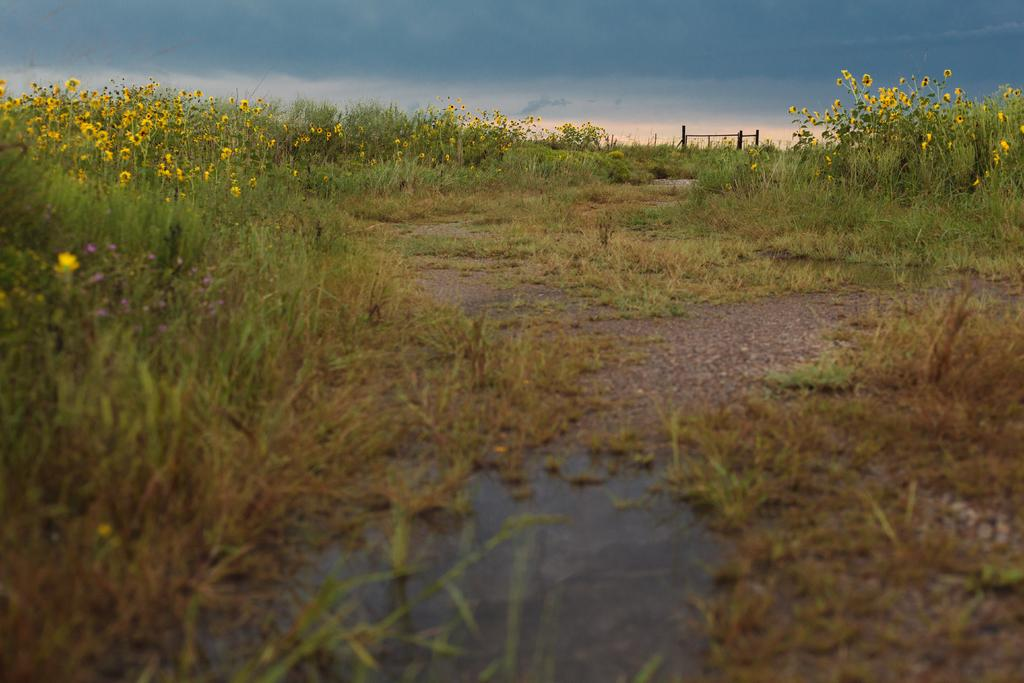What type of vegetation can be seen in the image? There are plants and flowers in the image. What type of ground cover is present in the image? There is grass in the image. What structures can be seen in the image? There are poles in the image. What natural element is visible in the image? Water is visible in the image. What is visible in the background of the image? The sky is visible in the background of the image. What can be seen in the sky? There are clouds in the sky. What type of cream can be seen on the books in the image? There are no books or cream present in the image. 